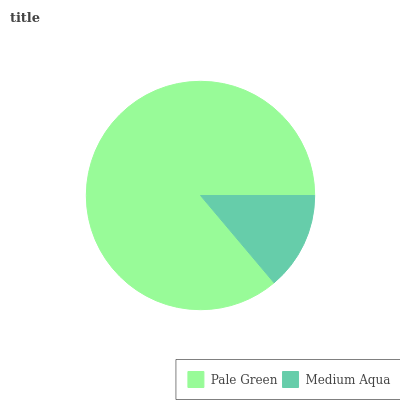Is Medium Aqua the minimum?
Answer yes or no. Yes. Is Pale Green the maximum?
Answer yes or no. Yes. Is Medium Aqua the maximum?
Answer yes or no. No. Is Pale Green greater than Medium Aqua?
Answer yes or no. Yes. Is Medium Aqua less than Pale Green?
Answer yes or no. Yes. Is Medium Aqua greater than Pale Green?
Answer yes or no. No. Is Pale Green less than Medium Aqua?
Answer yes or no. No. Is Pale Green the high median?
Answer yes or no. Yes. Is Medium Aqua the low median?
Answer yes or no. Yes. Is Medium Aqua the high median?
Answer yes or no. No. Is Pale Green the low median?
Answer yes or no. No. 